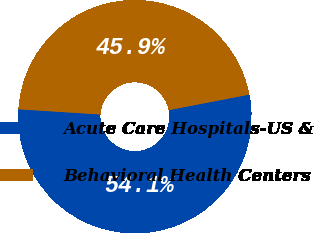<chart> <loc_0><loc_0><loc_500><loc_500><pie_chart><fcel>Acute Care Hospitals-US &<fcel>Behavioral Health Centers<nl><fcel>54.06%<fcel>45.94%<nl></chart> 